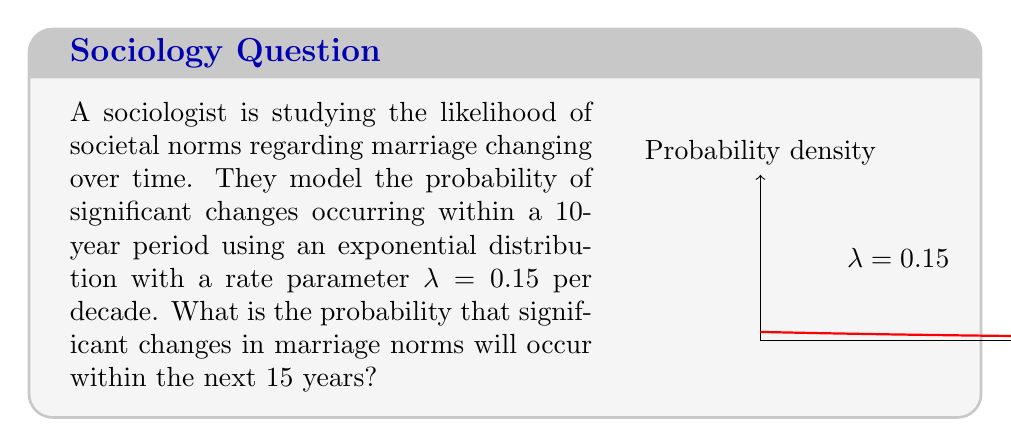What is the answer to this math problem? To solve this problem, we'll follow these steps:

1) The exponential distribution has the cumulative distribution function:
   
   $F(x) = 1 - e^{-λx}$

   where x is the time and λ is the rate parameter.

2) We're given λ = 0.15 per decade, but we need to find the probability for 15 years.
   First, convert 15 years to decades: 15 years = 1.5 decades

3) Now we can plug our values into the cumulative distribution function:

   $F(1.5) = 1 - e^{-0.15 * 1.5}$

4) Let's calculate this step-by-step:
   
   $F(1.5) = 1 - e^{-0.225}$
   
   $= 1 - 0.7985$ (rounded to 4 decimal places)
   
   $= 0.2015$

5) Convert to a percentage:
   
   0.2015 * 100% = 20.15%

Therefore, the probability of significant changes in marriage norms occurring within the next 15 years is approximately 20.15%.
Answer: 20.15% 